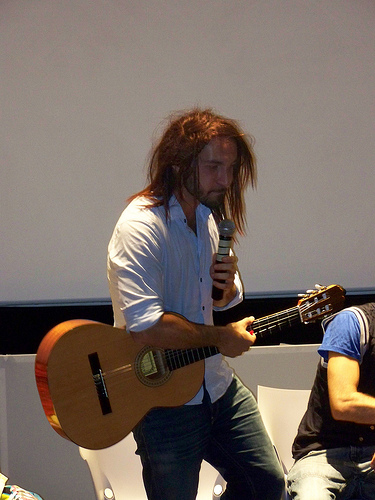<image>
Can you confirm if the string is on the guitar? Yes. Looking at the image, I can see the string is positioned on top of the guitar, with the guitar providing support. Is there a microphone on the guitar? No. The microphone is not positioned on the guitar. They may be near each other, but the microphone is not supported by or resting on top of the guitar. 